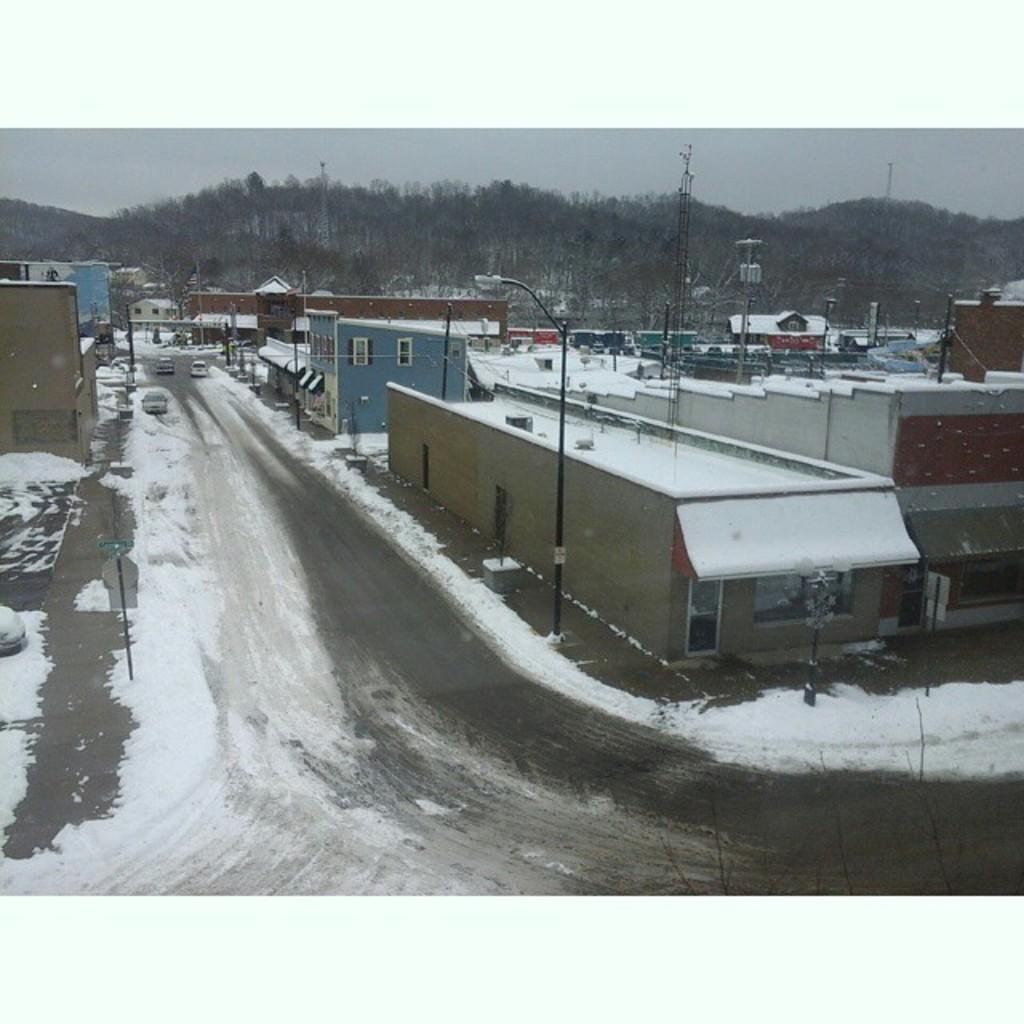Could you give a brief overview of what you see in this image? In the center of the image we can see the sky, clouds, trees, poles, buildings, sign boards, windows, snow, few vehicles on the road and a few other objects. 